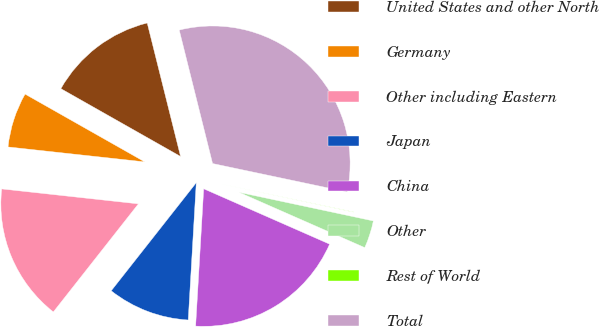Convert chart to OTSL. <chart><loc_0><loc_0><loc_500><loc_500><pie_chart><fcel>United States and other North<fcel>Germany<fcel>Other including Eastern<fcel>Japan<fcel>China<fcel>Other<fcel>Rest of World<fcel>Total<nl><fcel>12.9%<fcel>6.47%<fcel>16.12%<fcel>9.68%<fcel>19.34%<fcel>3.25%<fcel>0.03%<fcel>32.21%<nl></chart> 